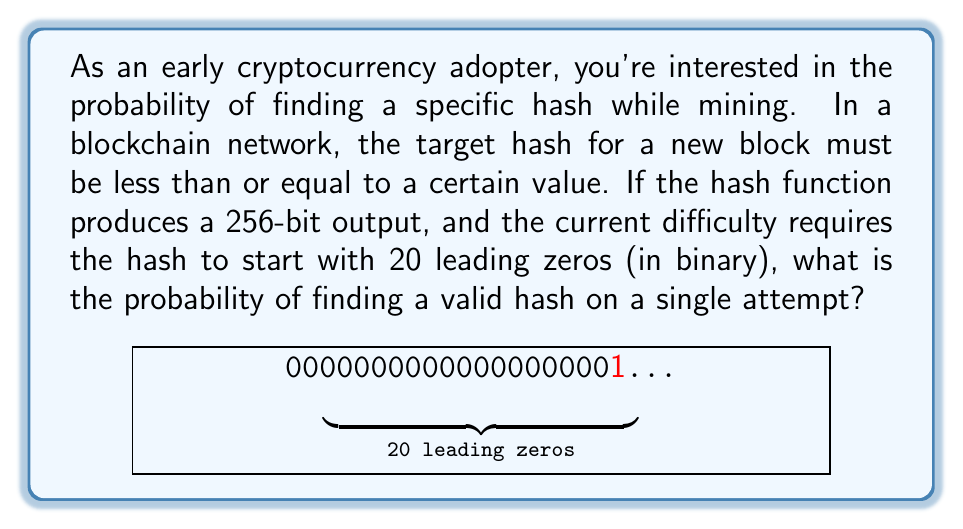Could you help me with this problem? Let's approach this step-by-step:

1) A 256-bit hash has $2^{256}$ possible values.

2) The requirement for 20 leading zeros means the first 20 bits must be 0, and the remaining 236 bits can be any value.

3) The number of valid hashes is thus $2^{236}$, as only the last 236 bits can vary.

4) The probability is the number of favorable outcomes divided by the total number of possible outcomes:

   $$P(\text{valid hash}) = \frac{\text{number of valid hashes}}{\text{total number of possible hashes}}$$

5) Substituting the values:

   $$P(\text{valid hash}) = \frac{2^{236}}{2^{256}}$$

6) Simplify:

   $$P(\text{valid hash}) = \frac{1}{2^{20}} = \frac{1}{1,048,576}$$

7) This can also be expressed as approximately $9.54 \times 10^{-7}$ or about 0.0000954%.
Answer: $\frac{1}{2^{20}}$ or $\frac{1}{1,048,576}$ 